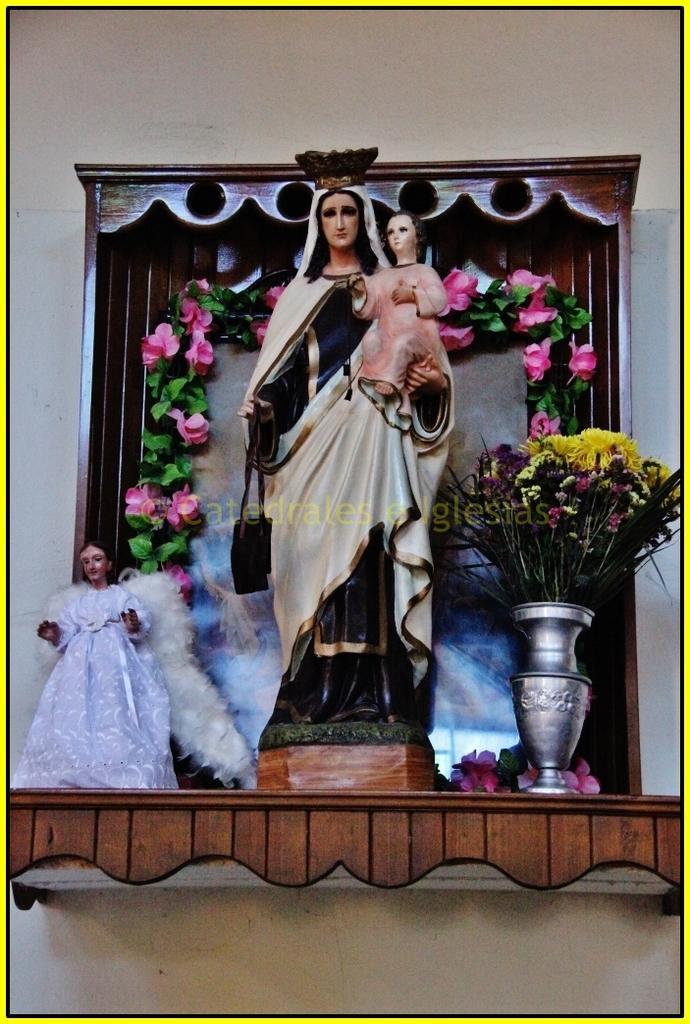Could you give a brief overview of what you see in this image? In this picture we can see a statue, on the right side there is a flower vase, we can see flowers, leaves and some text in the middle, in the background there is a wall. 